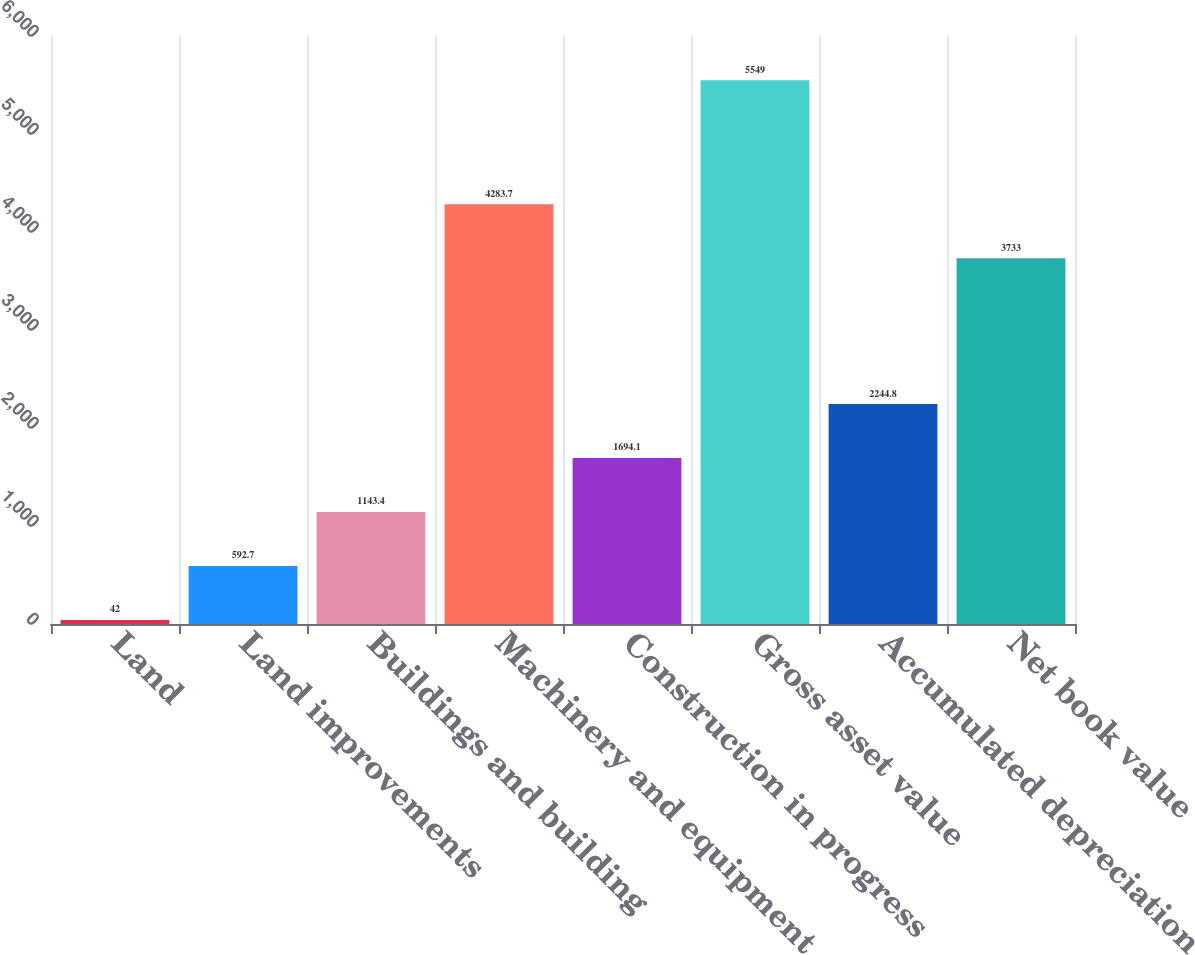<chart> <loc_0><loc_0><loc_500><loc_500><bar_chart><fcel>Land<fcel>Land improvements<fcel>Buildings and building<fcel>Machinery and equipment<fcel>Construction in progress<fcel>Gross asset value<fcel>Accumulated depreciation<fcel>Net book value<nl><fcel>42<fcel>592.7<fcel>1143.4<fcel>4283.7<fcel>1694.1<fcel>5549<fcel>2244.8<fcel>3733<nl></chart> 